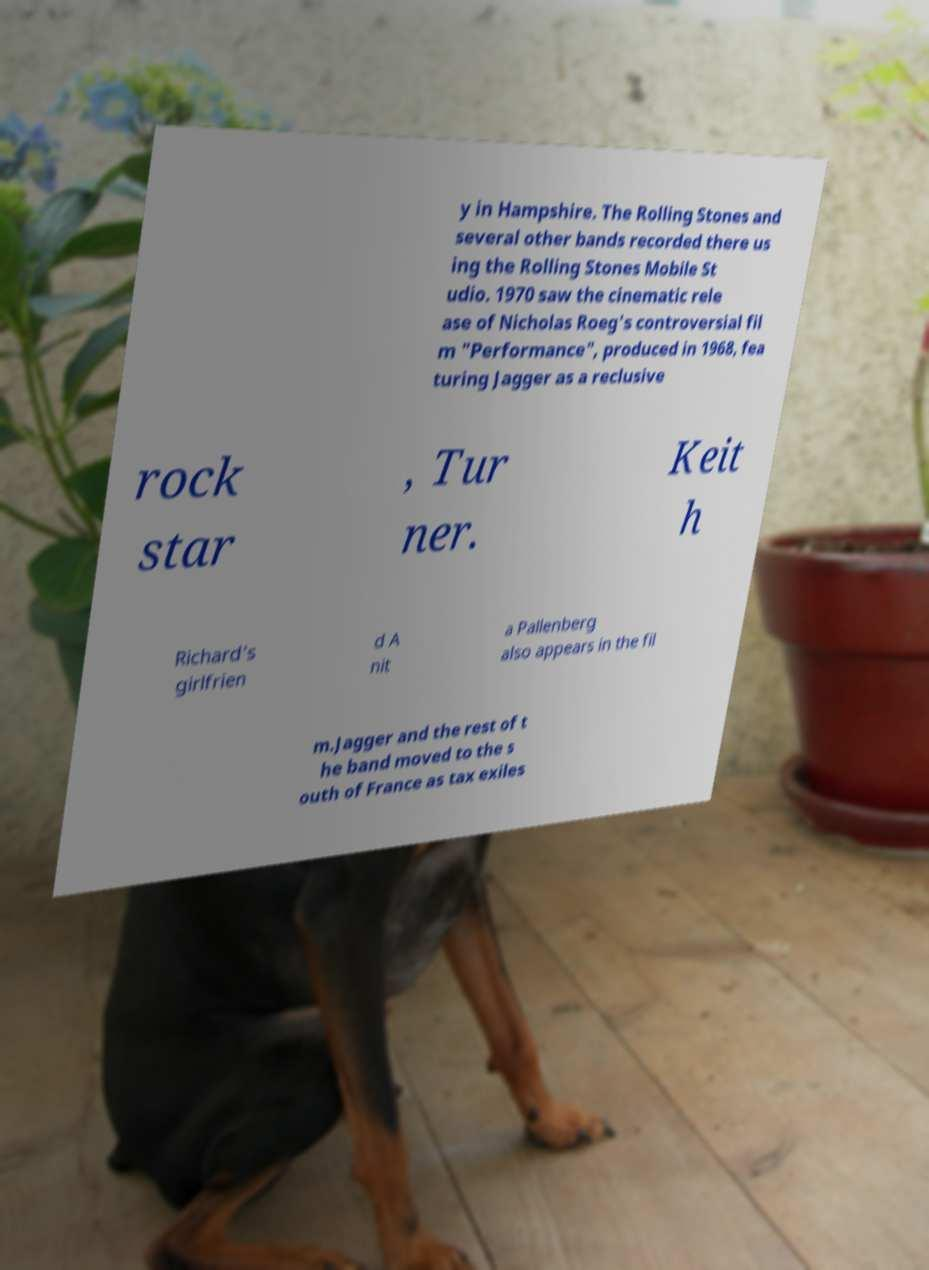Could you assist in decoding the text presented in this image and type it out clearly? y in Hampshire. The Rolling Stones and several other bands recorded there us ing the Rolling Stones Mobile St udio. 1970 saw the cinematic rele ase of Nicholas Roeg's controversial fil m "Performance", produced in 1968, fea turing Jagger as a reclusive rock star , Tur ner. Keit h Richard's girlfrien d A nit a Pallenberg also appears in the fil m.Jagger and the rest of t he band moved to the s outh of France as tax exiles 